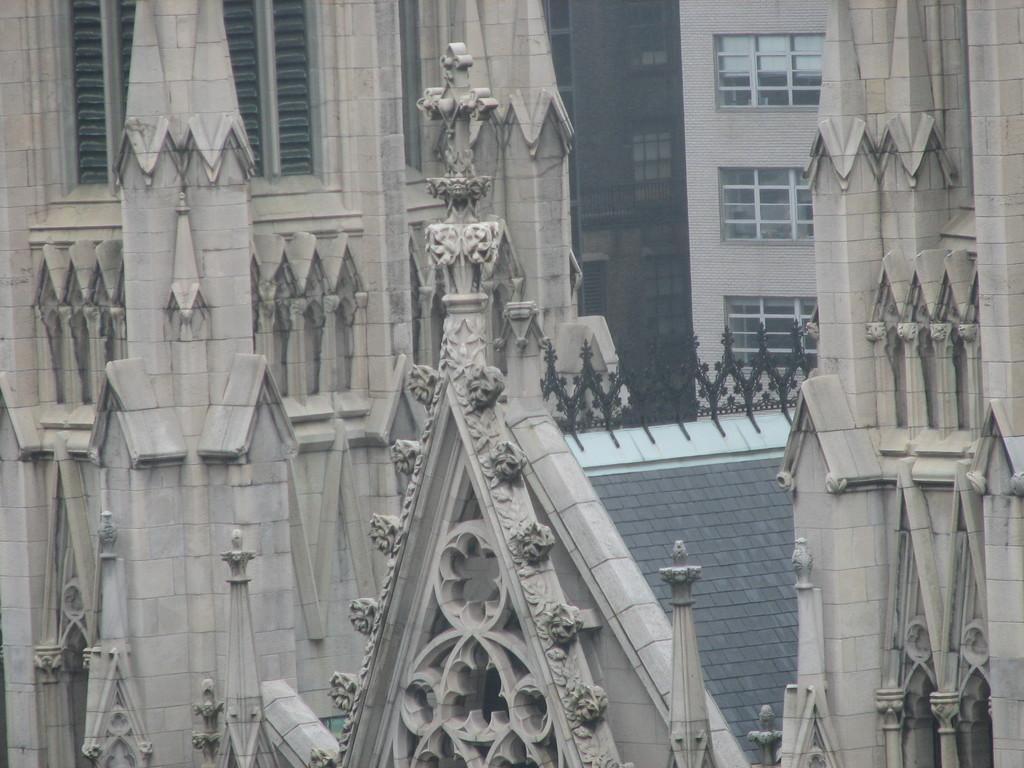Can you describe this image briefly? In this picture we can see the buildings with the windows. 